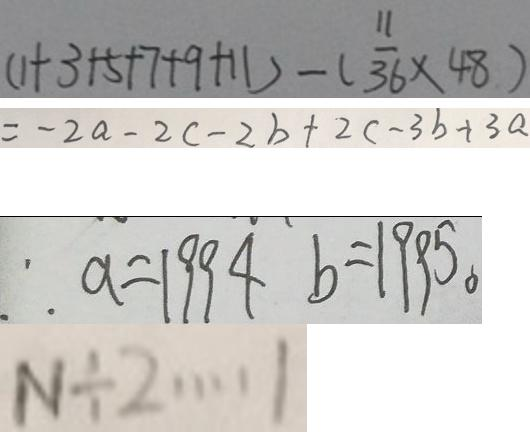<formula> <loc_0><loc_0><loc_500><loc_500>( 1 + 3 + 5 + 7 + 9 + 1 1 ) - ( \frac { 1 1 } { 3 6 } \times 4 8 ) 
 = - 2 a - 2 c - 2 b + 2 c - 3 b + 3 a 
 \therefore a = 1 9 9 4 b = 1 9 9 5 。 
 N \div 2 \cdots 1</formula> 